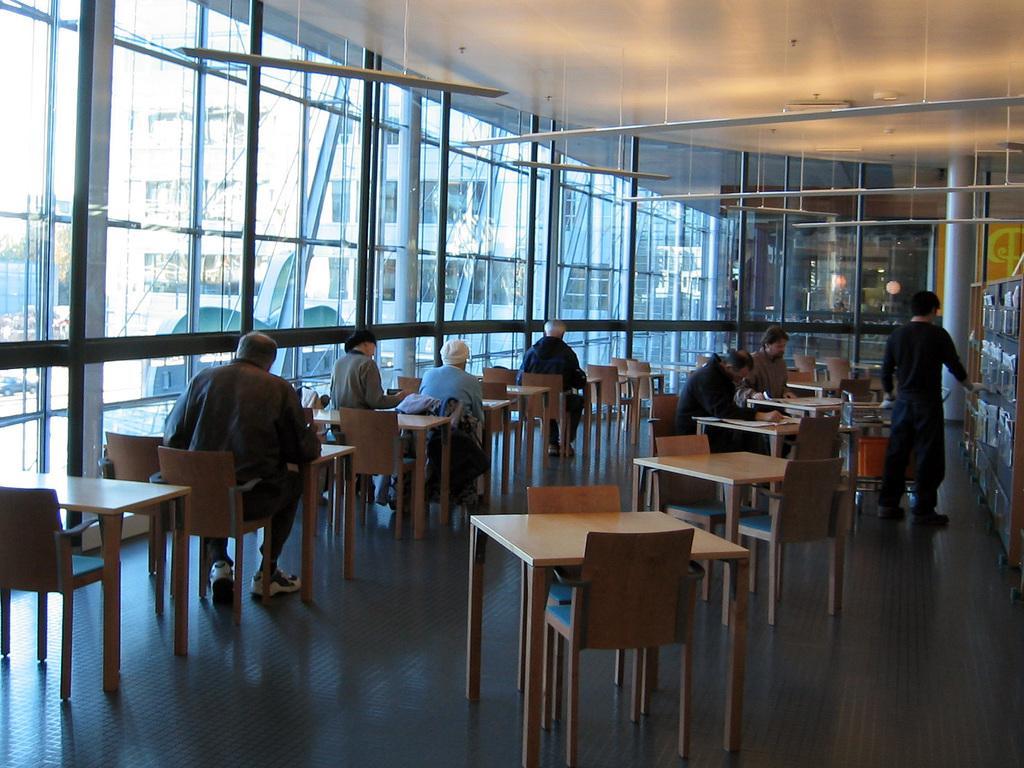Can you describe this image briefly? In this picture we can see a group of people some are sitting on chairs and one is standing and in front of them there is tables and bedside to them we have glasses, pillar, racks. 